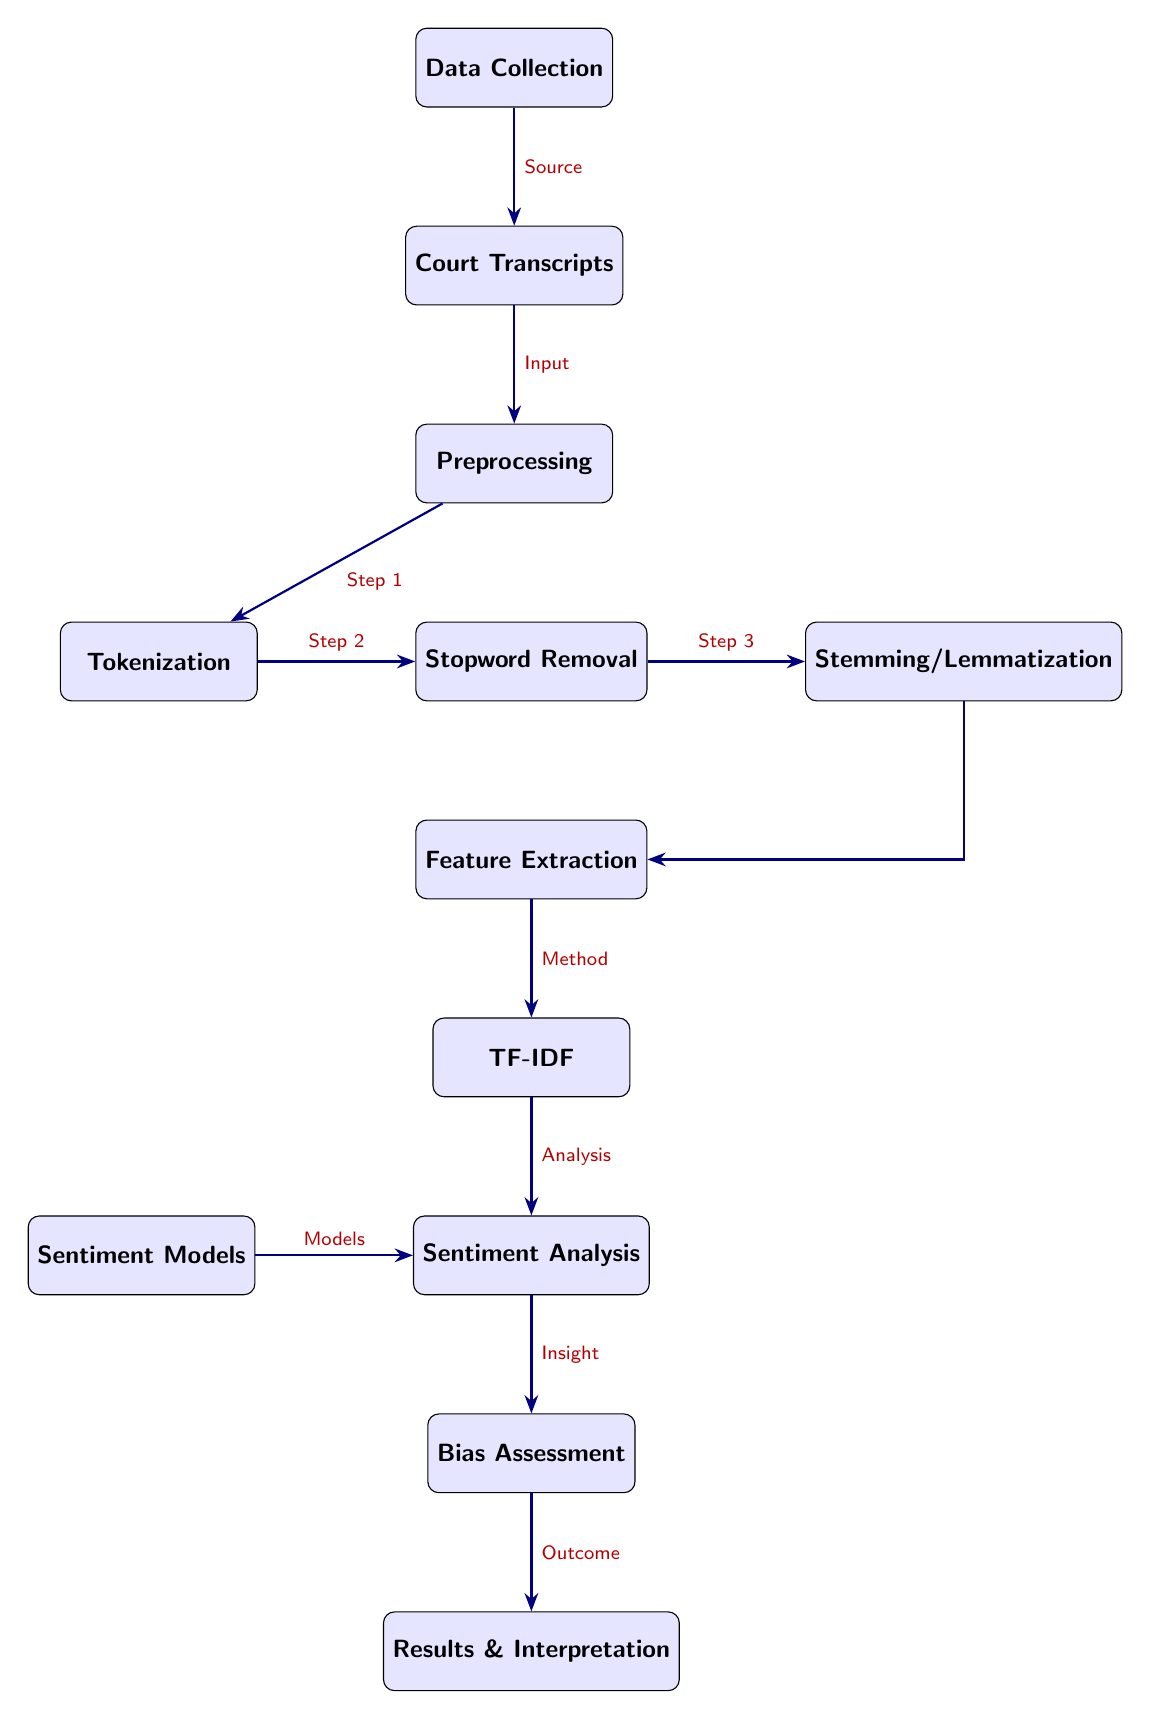What is the first step in the diagram? The diagram starts with the node labeled "Data Collection," indicating that this is the initial step in the process.
Answer: Data Collection How many preprocessing techniques are shown in the diagram? There are three techniques indicated in the diagram: Tokenization, Stopword Removal, and Stemming/Lemmatization, making a total of three preprocessing steps.
Answer: 3 What is the output of the "Sentiment Analysis" node? The output of the "Sentiment Analysis" node feeds into the "Bias Assessment" node, indicating that the analysis results are used to assess biases.
Answer: Bias Assessment Which node directly follows "Feature Extraction"? The node directly following "Feature Extraction" is "TF-IDF," which signifies the method used for extracting features from the preprocessed data.
Answer: TF-IDF What is the relationship between "Sentiment Models" and "Sentiment Analysis"? "Sentiment Models" serves as an input to the "Sentiment Analysis" node, indicating that various sentiment models are utilized in the analysis phase.
Answer: Models What is the last step of the diagram? The final step in the diagram is represented by the "Results & Interpretation" node, which shows the end of the process where results are interpreted.
Answer: Results & Interpretation Which preprocessing step occurs immediately after tokenization? The preprocessing step that occurs immediately after tokenization is "Stopword Removal," indicating the sequential flow in data processing.
Answer: Stopword Removal What does the "Bias Assessment" node rely on for its analysis? The analysis at the "Bias Assessment" node relies on the results from the "Sentiment Analysis" node, indicating that sentiment analysis outcomes are crucial for assessing juror biases.
Answer: Sentiment Analysis 